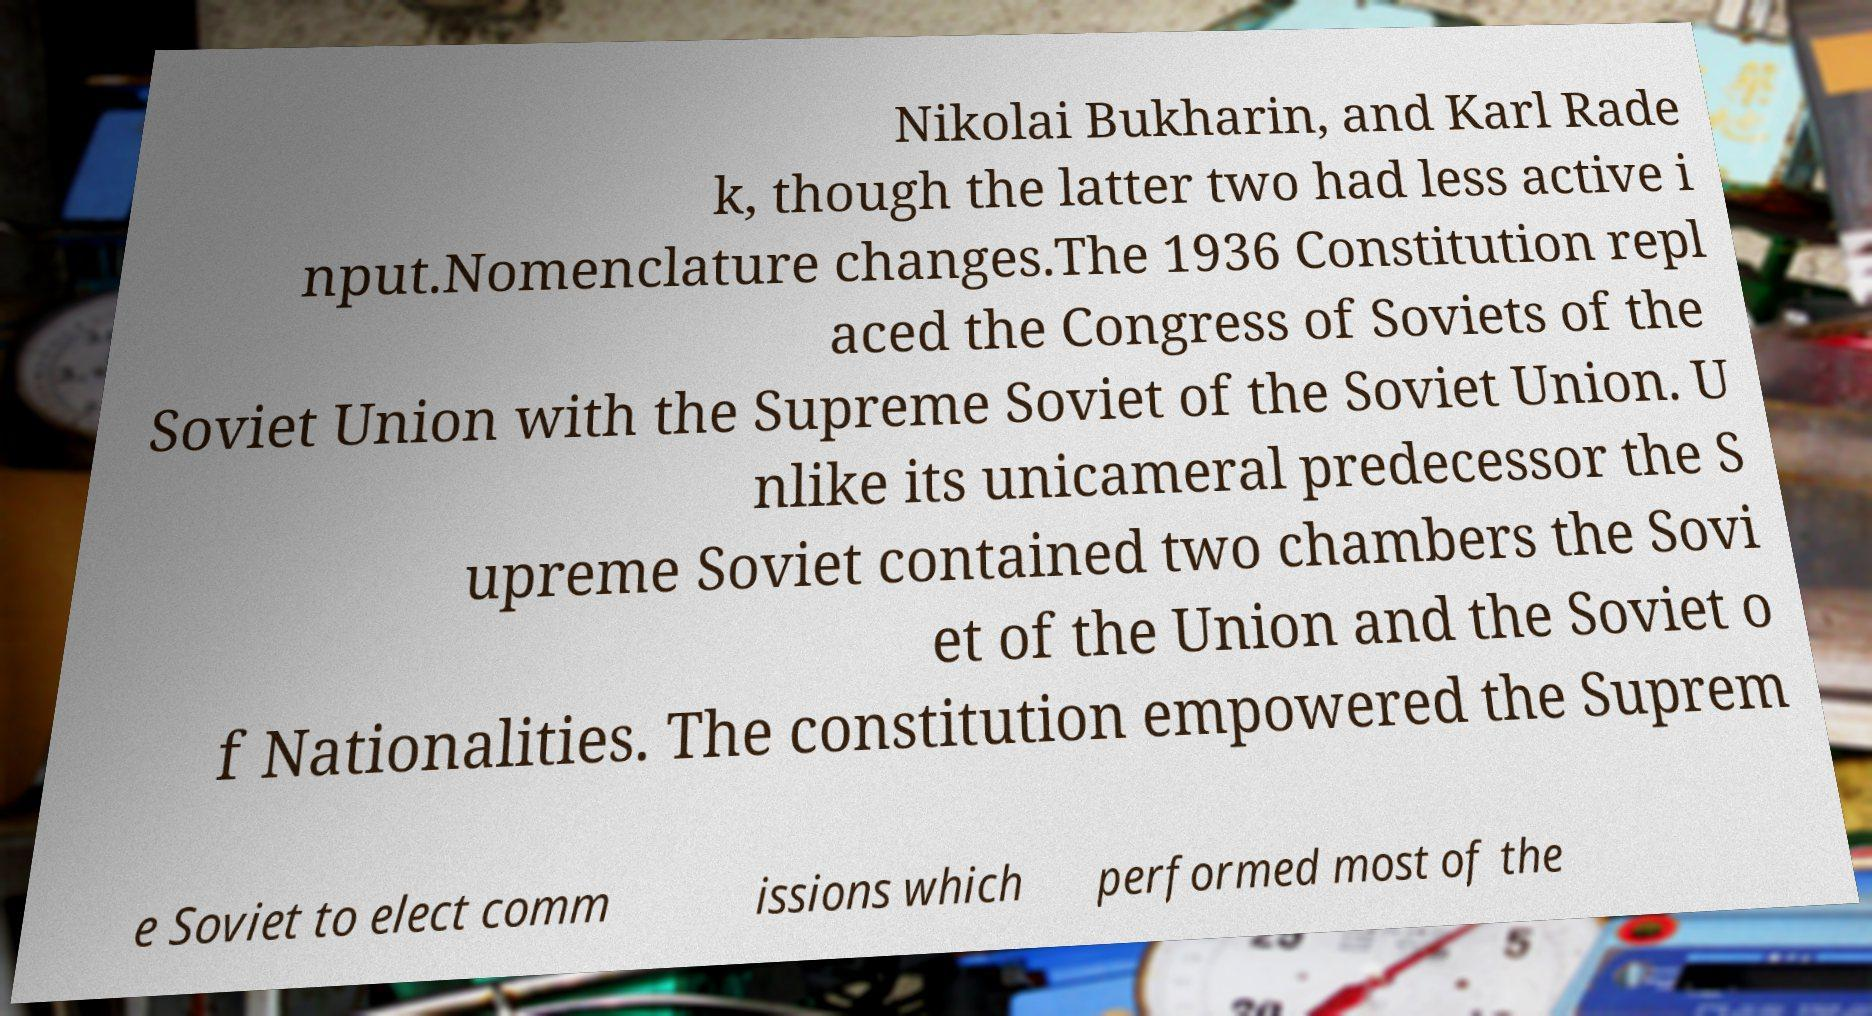Please identify and transcribe the text found in this image. Nikolai Bukharin, and Karl Rade k, though the latter two had less active i nput.Nomenclature changes.The 1936 Constitution repl aced the Congress of Soviets of the Soviet Union with the Supreme Soviet of the Soviet Union. U nlike its unicameral predecessor the S upreme Soviet contained two chambers the Sovi et of the Union and the Soviet o f Nationalities. The constitution empowered the Suprem e Soviet to elect comm issions which performed most of the 